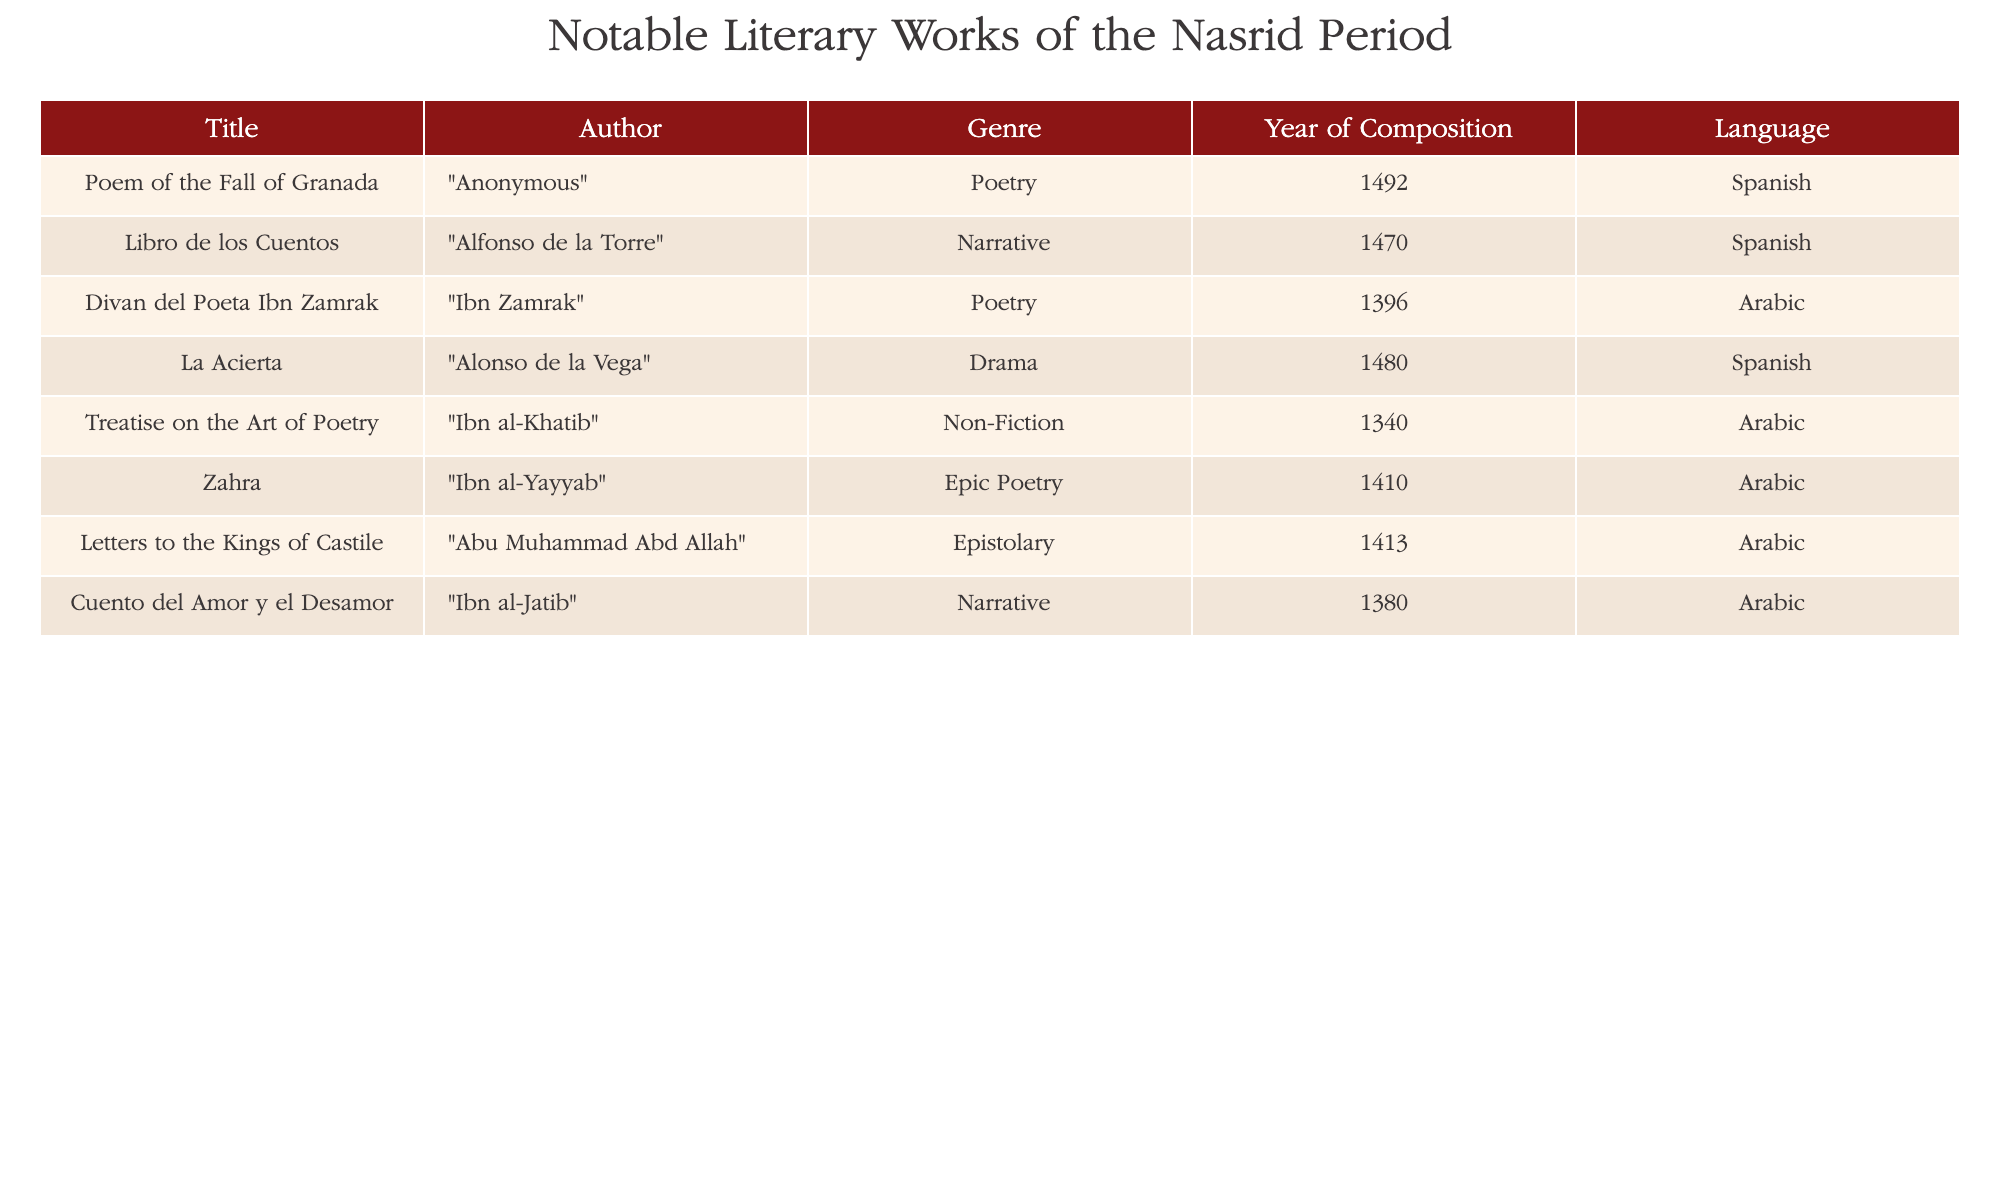What is the title of the work composed in 1492? The table lists various literary works along with their years of composition, and the year 1492 corresponds to "Poem of the Fall of Granada."
Answer: Poem of the Fall of Granada Who wrote "Cuento del Amor y el Desamor"? The author of "Cuento del Amor y el Desamor" is directly mentioned in the table. It clearly indicates that the author is Ibn al-Jatib.
Answer: Ibn al-Jatib How many works were written in Arabic? Counting the entries in the table that have Arabic listed as the language, we find 5 works: "Divan del Poeta Ibn Zamrak," "Treatise on the Art of Poetry," "Zahra," "Letters to the Kings of Castile," and "Cuento del Amor y el Desamor."
Answer: 5 Is "La Acierta" a work of poetry? The table categorizes "La Acierta" under the genre of Drama, meaning it is not a work of poetry. Therefore, the answer is based on this classification.
Answer: No What is the average year of composition for the works written in Spanish? The years of works in Spanish are 1492, 1470, and 1480. Summing these values gives 1492 + 1470 + 1480 = 4442. There are three works, so the average year is 4442 / 3 = 1480.67, which we can round to 1481 for a whole year representation.
Answer: 1481 Which author has the most works represented in the table? By analyzing the author column in the table, we see that each author is listed once, implying there are no repeat authors. Since all authors have one work each, there is a tie.
Answer: None, all authors have one work What genre does "Divan del Poeta Ibn Zamrak" belong to? The table lists the genre of "Divan del Poeta Ibn Zamrak," which is categorized as Poetry.
Answer: Poetry In what language is "Treatise on the Art of Poetry" written? The table specifies the language associated with "Treatise on the Art of Poetry," which is Arabic.
Answer: Arabic 